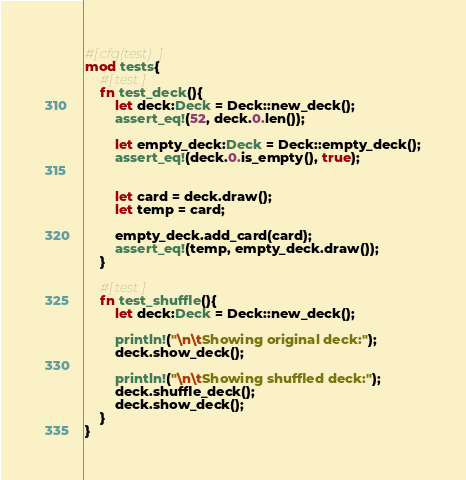<code> <loc_0><loc_0><loc_500><loc_500><_Rust_>#[cfg(test)]
mod tests{
    #[test]
    fn test_deck(){
        let deck:Deck = Deck::new_deck();
        assert_eq!(52, deck.0.len());

        let empty_deck:Deck = Deck::empty_deck();
        assert_eq!(deck.0.is_empty(), true);
        
       
        let card = deck.draw();
        let temp = card;

        empty_deck.add_card(card);
        assert_eq!(temp, empty_deck.draw());
    }

    #[test]
    fn test_shuffle(){
        let deck:Deck = Deck::new_deck();

        println!("\n\tShowing original deck:");
        deck.show_deck();

        println!("\n\tShowing shuffled deck:");
        deck.shuffle_deck();
        deck.show_deck();
    }
}
</code> 